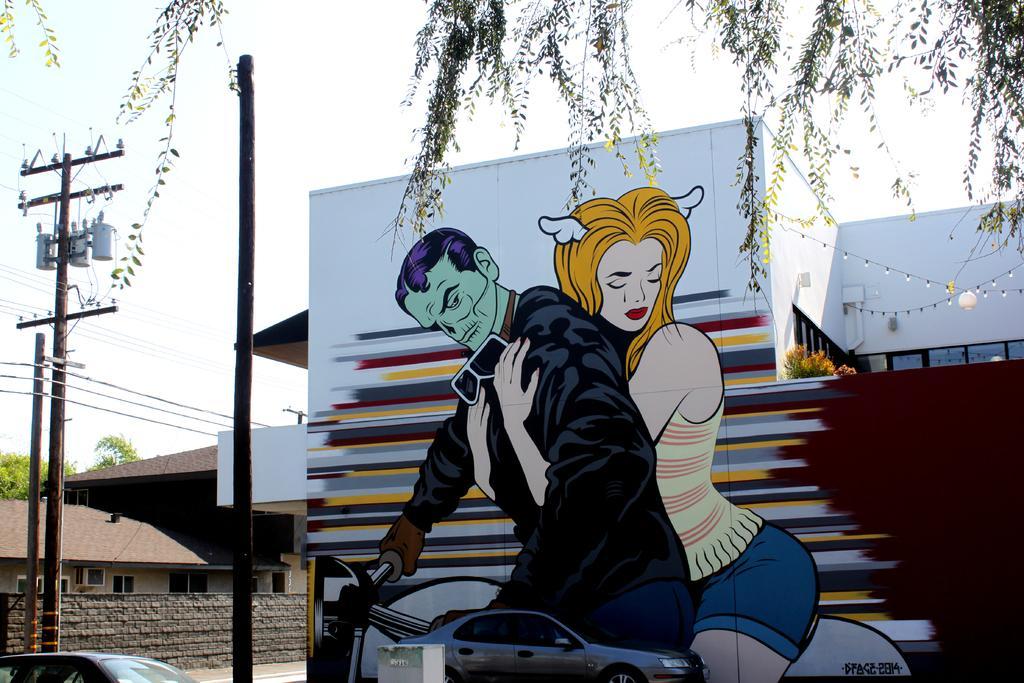Describe this image in one or two sentences. In this image we can see there is a painting wall. There are houses, poles and vehicles. In the background we can see the sky.  